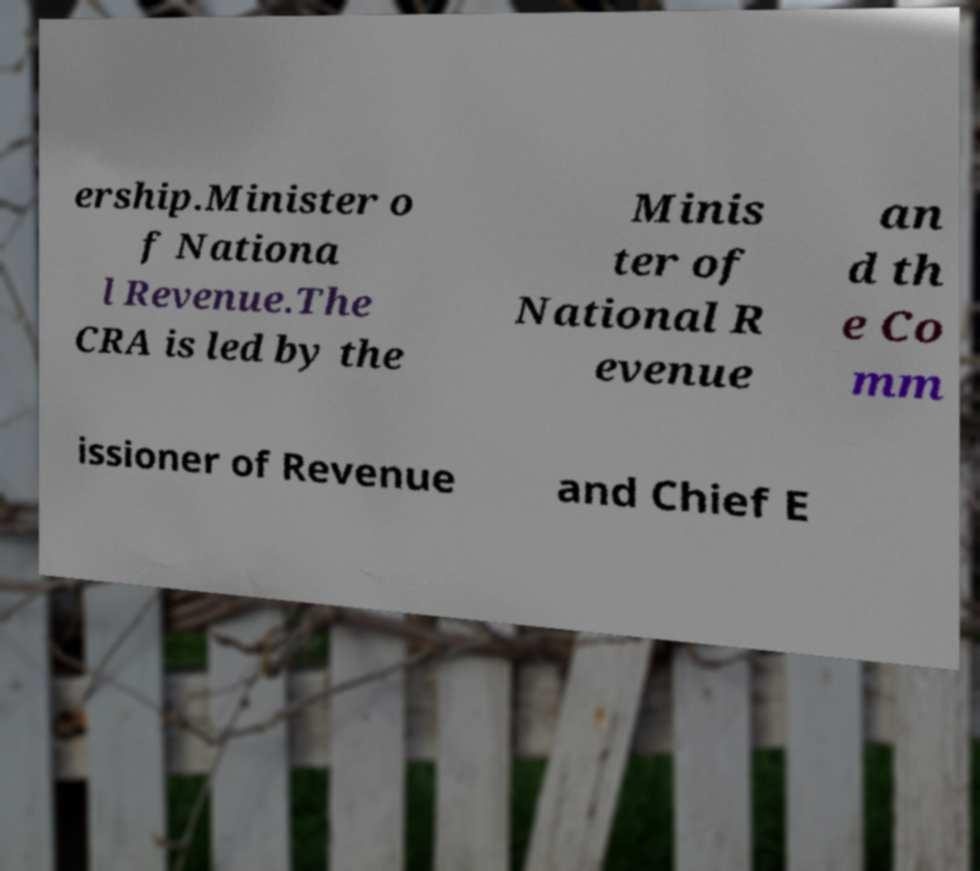Can you accurately transcribe the text from the provided image for me? ership.Minister o f Nationa l Revenue.The CRA is led by the Minis ter of National R evenue an d th e Co mm issioner of Revenue and Chief E 